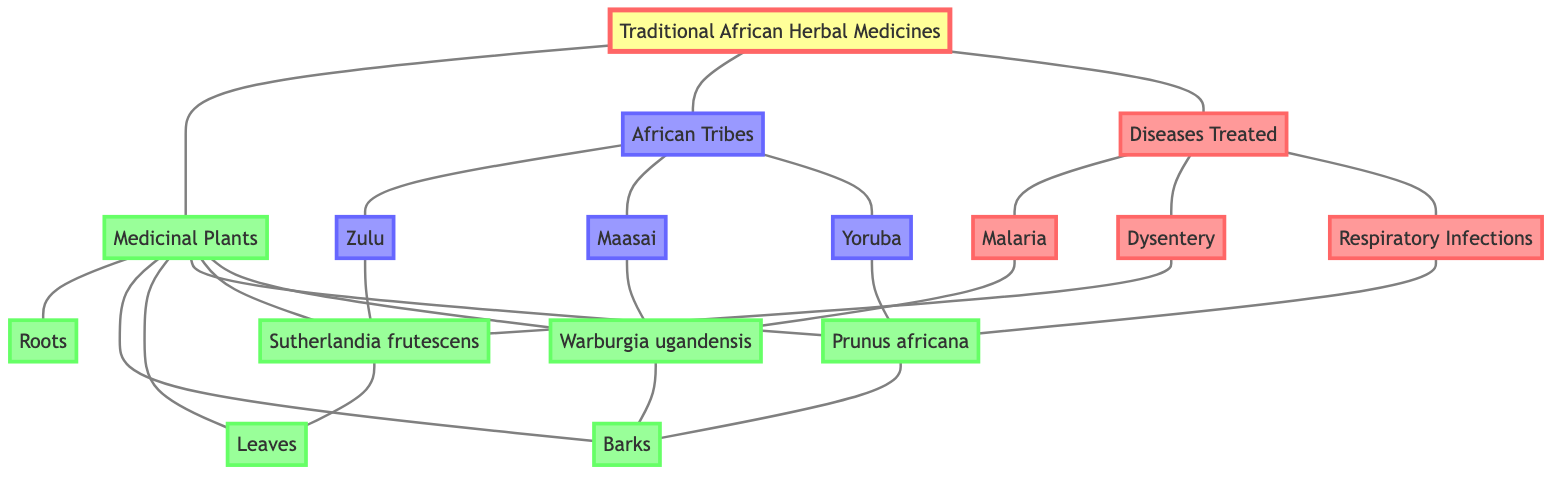What is the main focus of the diagram? The diagram illustrates the relationships between Traditional African Herbal Medicines and their sources, including medicinal plants, tribes, and diseases treated.
Answer: Traditional African Herbal Medicines How many tribes are represented in the diagram? There are three tribes depicted: Zulu, Maasai, and Yoruba. Each tribe connects to specific medicinal plants.
Answer: 3 Which medicinal plant is associated with the Zulu tribe? The Zulu tribe is linked to the medicinal plant Sutherlandia frutescens, as indicated by the connection in the diagram.
Answer: Sutherlandia frutescens What types of plant sources are identified in the graph? The diagram specifies three types of plant sources: roots, barks, and leaves, as shown by the direct connections to the medicinal plants node.
Answer: Roots, Barks, Leaves Which disease is treated by Warburgia ugandensis? The diagram indicates that Warburgia ugandensis is used to treat malaria, as it is directly connected to the malaria node.
Answer: Malaria How many medicinal plants are mentioned in the diagram? The diagram lists three medicinal plants: Prunus africana, Sutherlandia frutescens, and Warburgia ugandensis.
Answer: 3 Which tribe uses Prunus africana? The Yoruba tribe is associated with Prunus africana, as indicated by their direct connection in the diagram.
Answer: Yoruba What is the relationship between dysentery and Sutherlandia frutescens? The diagram shows that Sutherlandia frutescens is used to treat dysentery, which is indicated by the direct connection between the two nodes.
Answer: Treats Which type of graph is presented? The diagram depicts an undirected graph where the relationships between nodes are bidirectional, meaning the connections do not have a specific direction.
Answer: Undirected Graph How many edges are present in the diagram? To determine the number of edges, count the connections between nodes. The diagram has twenty edges connecting the nodes together.
Answer: 20 